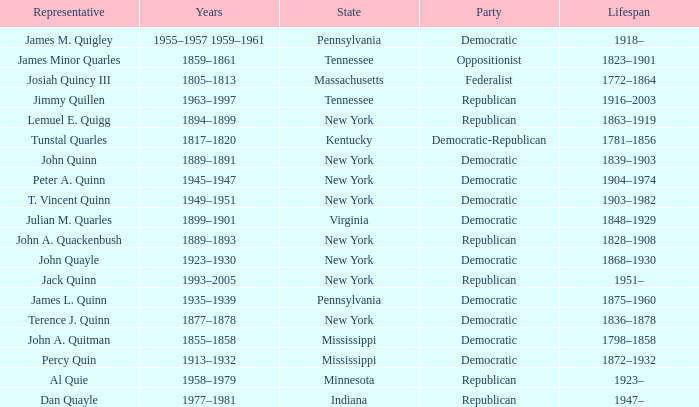Which state does Jimmy Quillen represent? Tennessee. 